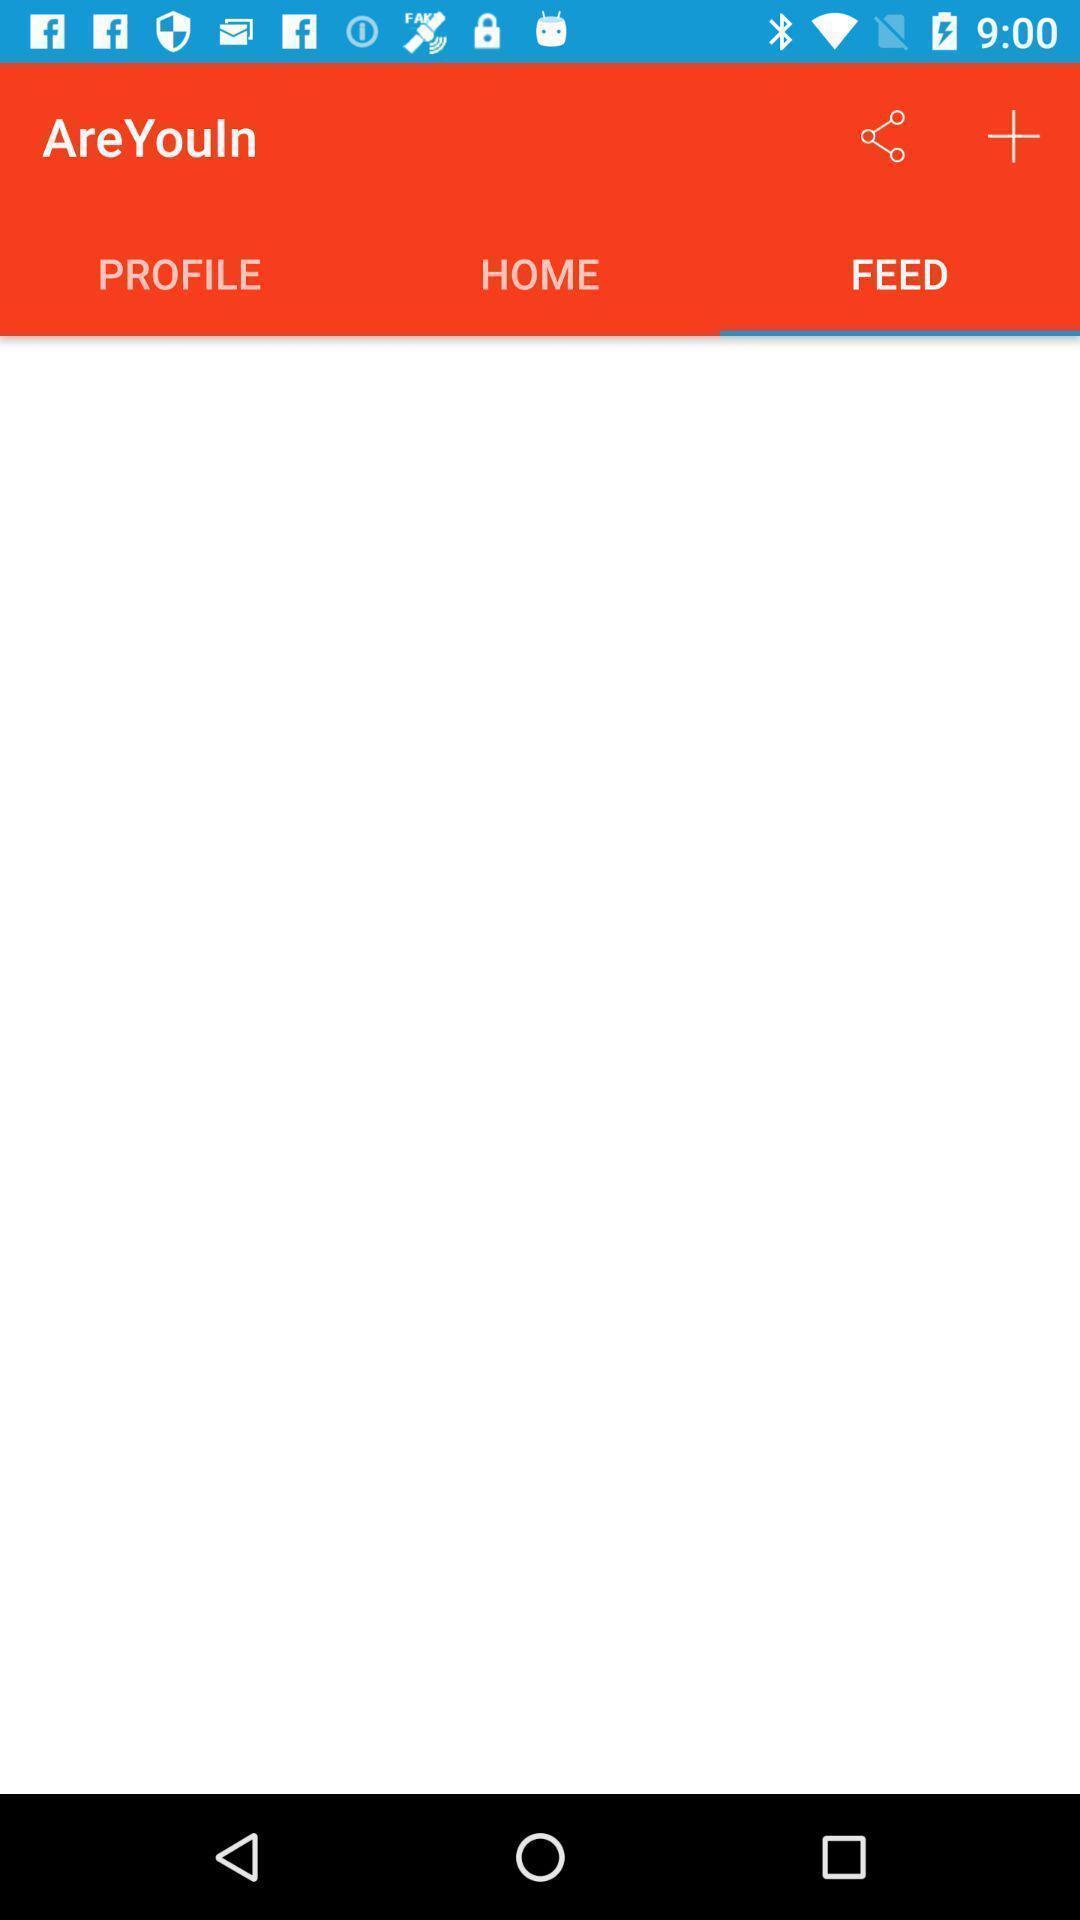Please provide a description for this image. Window displaying a online marketing app. 